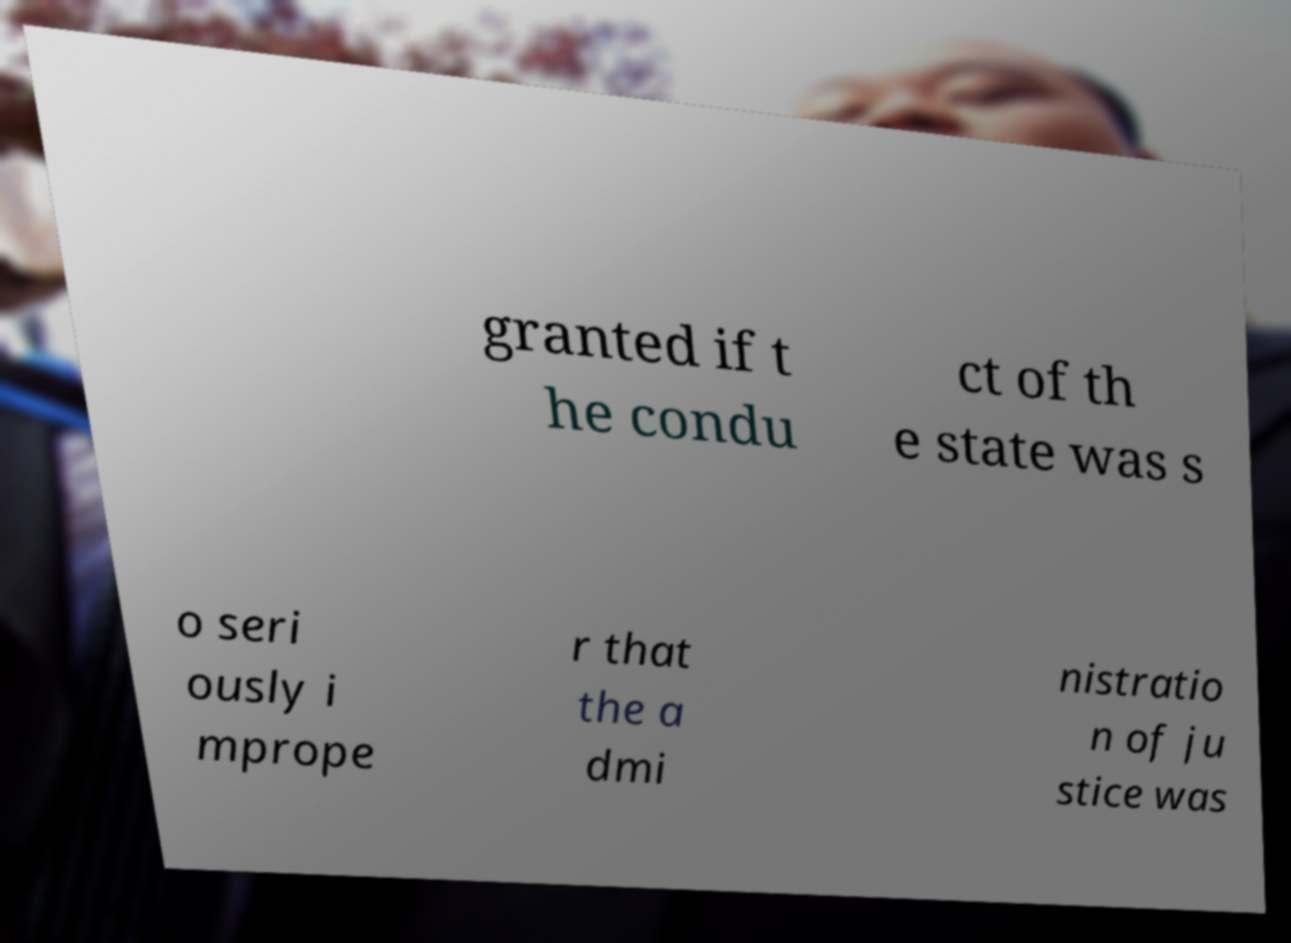Could you extract and type out the text from this image? granted if t he condu ct of th e state was s o seri ously i mprope r that the a dmi nistratio n of ju stice was 